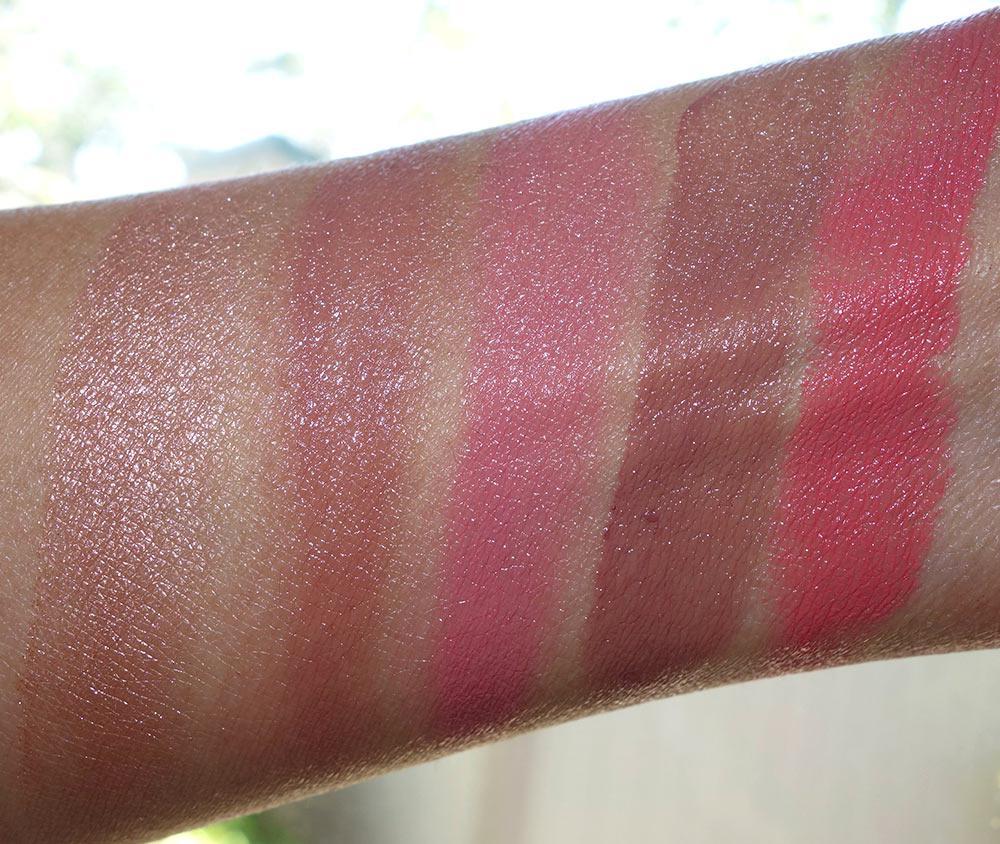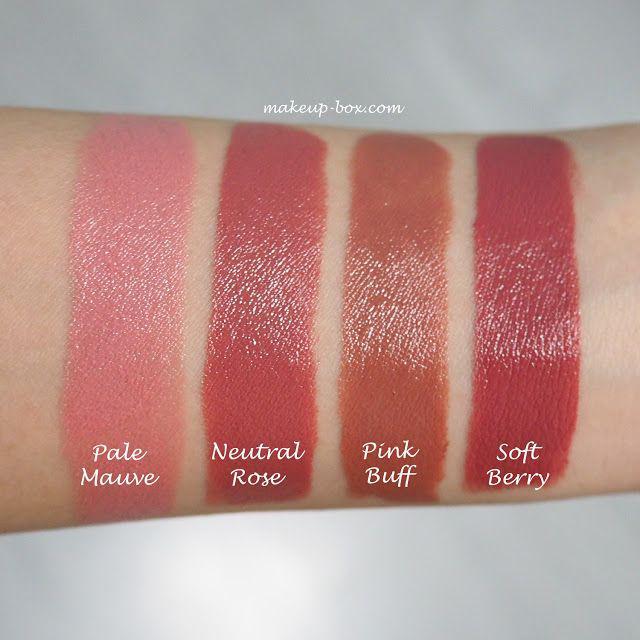The first image is the image on the left, the second image is the image on the right. For the images shown, is this caption "The person on the left is lighter skinned than the person on the right." true? Answer yes or no. No. The first image is the image on the left, the second image is the image on the right. For the images displayed, is the sentence "There are at least 13 stripes of different lipstick colors on the arms." factually correct? Answer yes or no. No. 